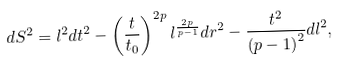<formula> <loc_0><loc_0><loc_500><loc_500>d S ^ { 2 } = l ^ { 2 } d t ^ { 2 } - \left ( \frac { t } { t _ { 0 } } \right ) ^ { 2 p } l ^ { \frac { 2 p } { p - 1 } } d r ^ { 2 } - \frac { t ^ { 2 } } { \left ( p - 1 \right ) ^ { 2 } } d l ^ { 2 } ,</formula> 